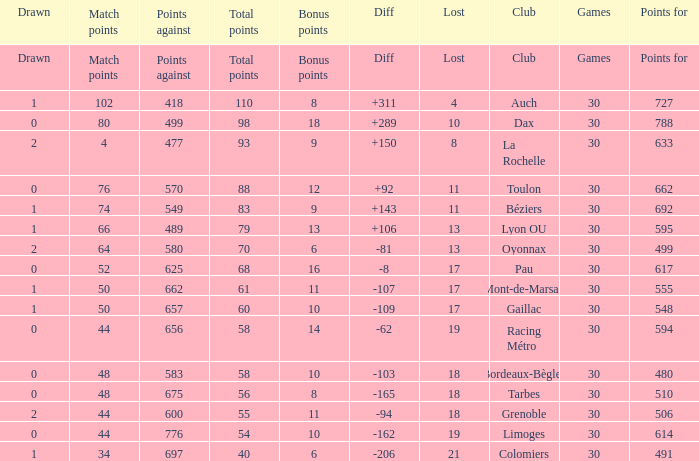What is the number of games for a club that has 34 match points? 30.0. 